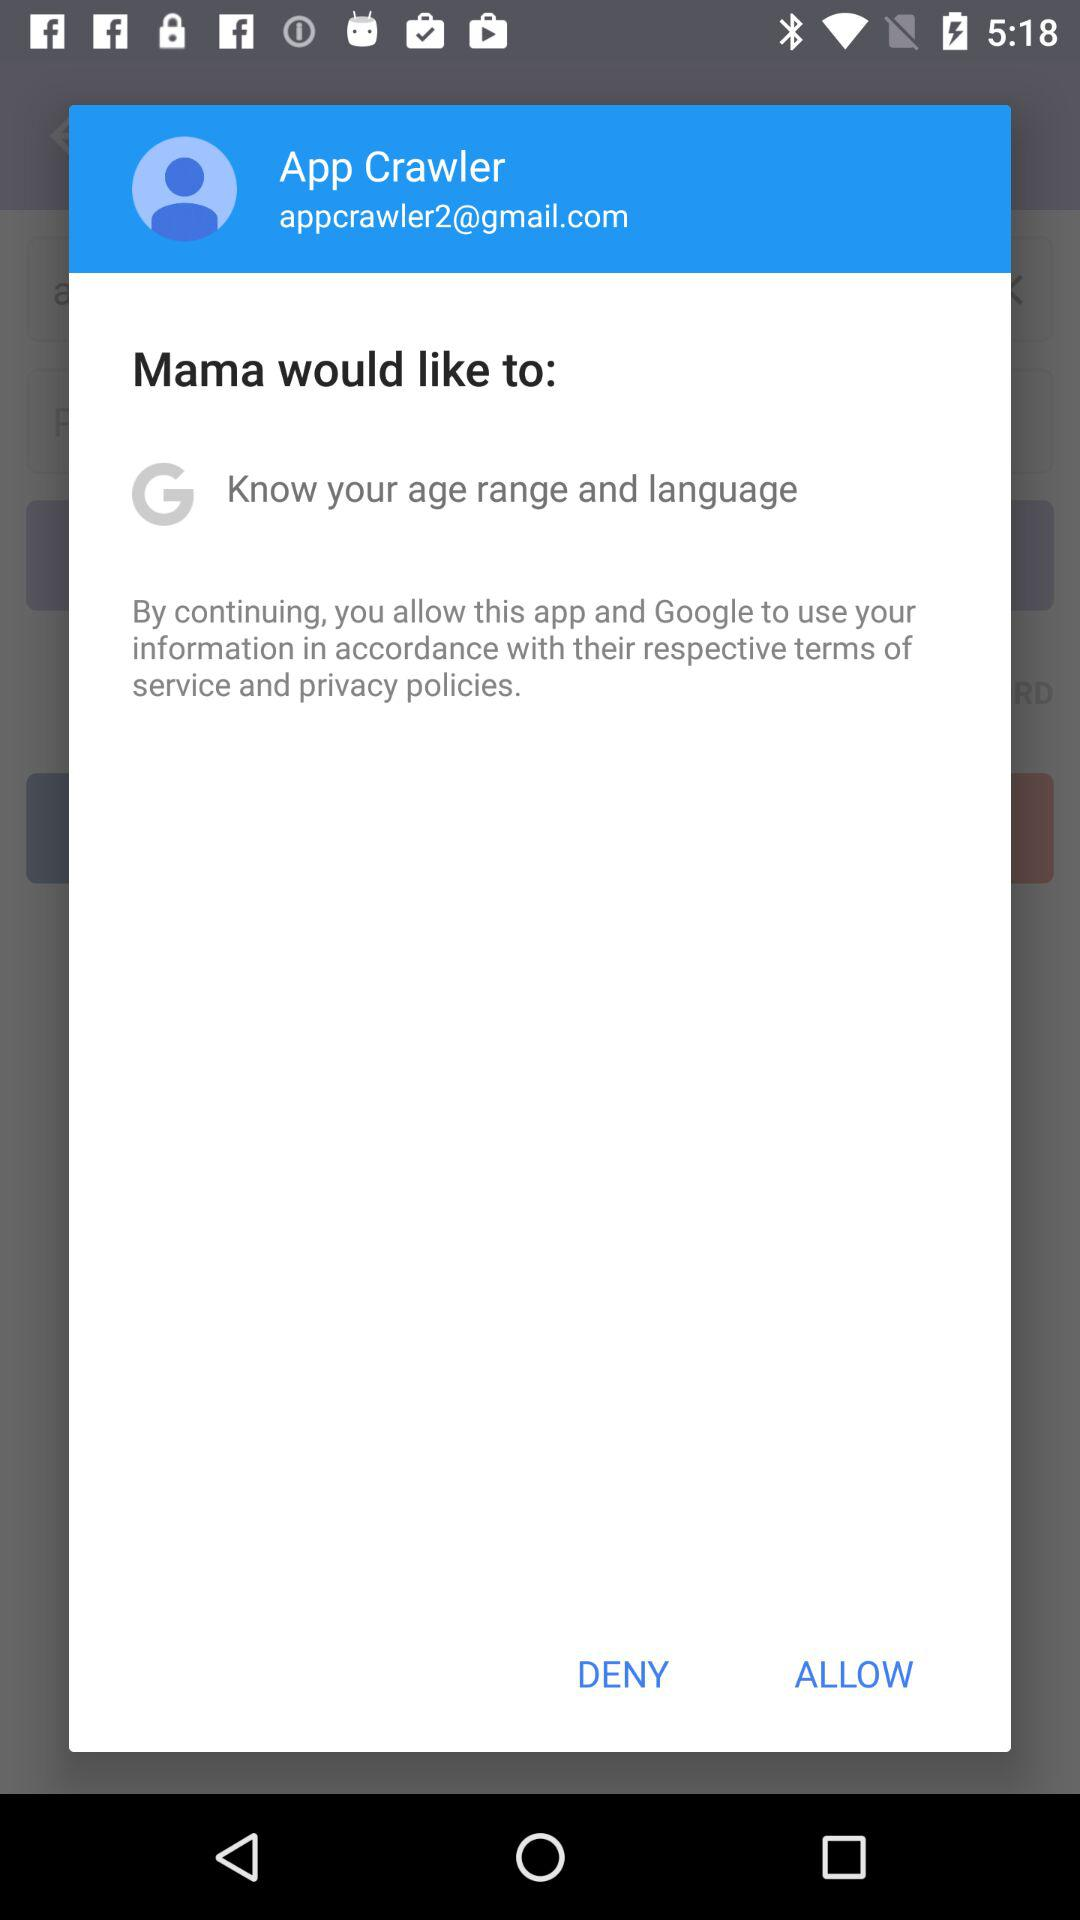What is the email address? The email address is appcrawler2@gmail.com. 